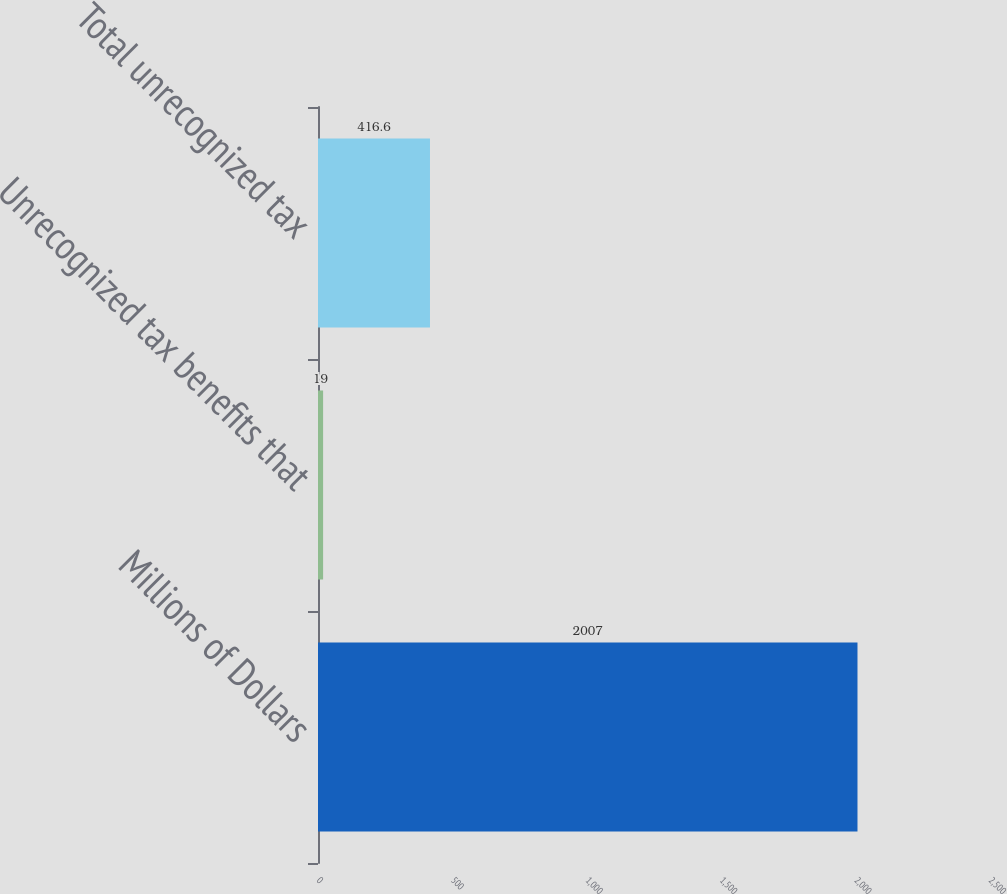Convert chart. <chart><loc_0><loc_0><loc_500><loc_500><bar_chart><fcel>Millions of Dollars<fcel>Unrecognized tax benefits that<fcel>Total unrecognized tax<nl><fcel>2007<fcel>19<fcel>416.6<nl></chart> 